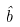Convert formula to latex. <formula><loc_0><loc_0><loc_500><loc_500>\hat { b }</formula> 